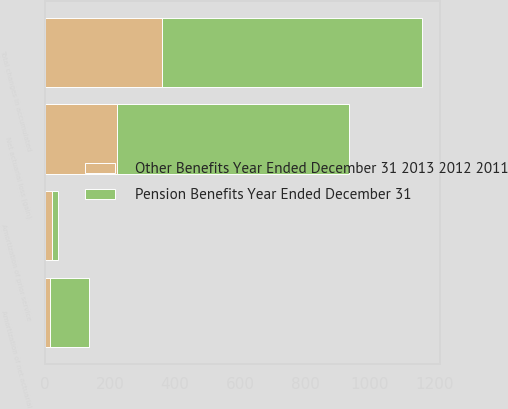<chart> <loc_0><loc_0><loc_500><loc_500><stacked_bar_chart><ecel><fcel>Amortization of prior service<fcel>Net actuarial loss (gain)<fcel>Amortization of net actuarial<fcel>Total changes in accumulated<nl><fcel>Pension Benefits Year Ended December 31<fcel>18<fcel>716<fcel>118<fcel>798<nl><fcel>Other Benefits Year Ended December 31 2013 2012 2011<fcel>21<fcel>220<fcel>16<fcel>361<nl></chart> 